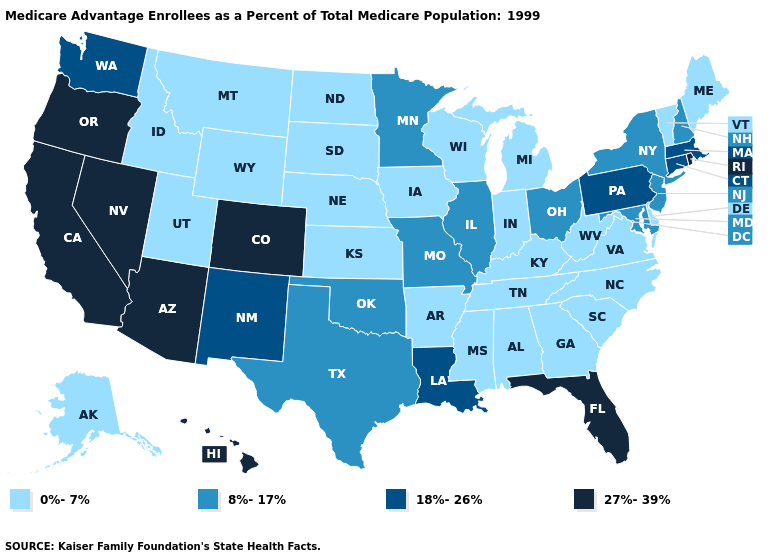Name the states that have a value in the range 18%-26%?
Give a very brief answer. Connecticut, Louisiana, Massachusetts, New Mexico, Pennsylvania, Washington. What is the value of Vermont?
Be succinct. 0%-7%. What is the lowest value in the MidWest?
Write a very short answer. 0%-7%. Does the first symbol in the legend represent the smallest category?
Short answer required. Yes. Name the states that have a value in the range 18%-26%?
Quick response, please. Connecticut, Louisiana, Massachusetts, New Mexico, Pennsylvania, Washington. Is the legend a continuous bar?
Concise answer only. No. What is the value of Rhode Island?
Answer briefly. 27%-39%. Which states have the highest value in the USA?
Short answer required. Arizona, California, Colorado, Florida, Hawaii, Nevada, Oregon, Rhode Island. Name the states that have a value in the range 0%-7%?
Answer briefly. Alaska, Alabama, Arkansas, Delaware, Georgia, Iowa, Idaho, Indiana, Kansas, Kentucky, Maine, Michigan, Mississippi, Montana, North Carolina, North Dakota, Nebraska, South Carolina, South Dakota, Tennessee, Utah, Virginia, Vermont, Wisconsin, West Virginia, Wyoming. Name the states that have a value in the range 0%-7%?
Concise answer only. Alaska, Alabama, Arkansas, Delaware, Georgia, Iowa, Idaho, Indiana, Kansas, Kentucky, Maine, Michigan, Mississippi, Montana, North Carolina, North Dakota, Nebraska, South Carolina, South Dakota, Tennessee, Utah, Virginia, Vermont, Wisconsin, West Virginia, Wyoming. What is the lowest value in the USA?
Give a very brief answer. 0%-7%. What is the value of Alabama?
Give a very brief answer. 0%-7%. What is the lowest value in the USA?
Keep it brief. 0%-7%. Is the legend a continuous bar?
Write a very short answer. No. Does the first symbol in the legend represent the smallest category?
Be succinct. Yes. 